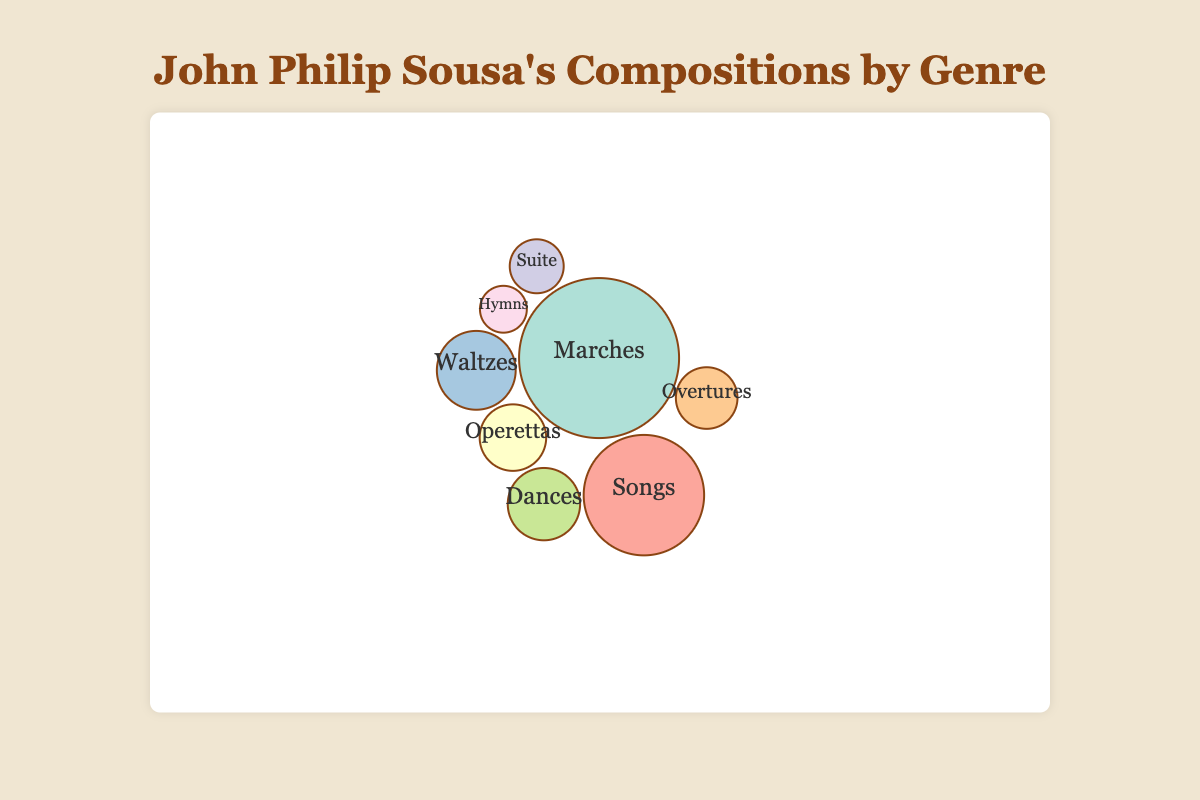How many genres are represented in the bubble chart? By counting the unique genres listed in the data, we find there are 8 genres total.
Answer: 8 What is the most represented genre in Sousa's compositions? By examining the bubbles, the largest one corresponds to the "Marches" genre, indicating it has the highest number of pieces at 136.
Answer: Marches Which genre has the fewest number of pieces? The smallest bubble represents the "Hymns" genre, which has only 5 pieces.
Answer: Hymns How many more pieces are there in the "Marches" genre compared to the "Songs" genre? The "Marches" genre has 136 pieces, and the "Songs" genre has 70 pieces. The difference is 136 - 70 = 66.
Answer: 66 What are the well-known pieces in the "Operettas" genre? The tooltip for the "Operettas" bubble lists famous pieces such as "El Capitan," "The Bride Elect," and "The Charlatan."
Answer: El Capitan, The Bride Elect, The Charlatan What is the combined number of pieces in the "Waltzes" and "Dances" genres? The "Waltzes" genre has 24 pieces, and the "Dances" genre has 19 pieces. Combined, they have 24 + 19 = 43 pieces.
Answer: 43 Which two genres have the closest number of pieces, and what are their counts? "Dances" with 19 pieces and "Overtures" with 12 pieces have the closest counts, with a difference of 7 pieces.
Answer: Dances (19) and Overtures (12) How does the number of pieces in the "Suite" genre compare to the "Overtures"? The "Suite" genre has 8 pieces, while the "Overtures" genre has 12 pieces, so "Overtures" has 4 more pieces than "Suites".
Answer: Overtures have 4 more pieces than Suite What is the average number of pieces across all genres? Summing the total number of pieces (136 + 15 + 8 + 70 + 24 + 12 + 19 + 5 = 289) and dividing by the number of genres (8), the average is 289 / 8 = 36.125.
Answer: 36.125 Which genre's famous pieces include "Sweet and Low"? According to the tooltip for the "Songs" genre, "Sweet and Low" is listed as a famous piece.
Answer: Songs 